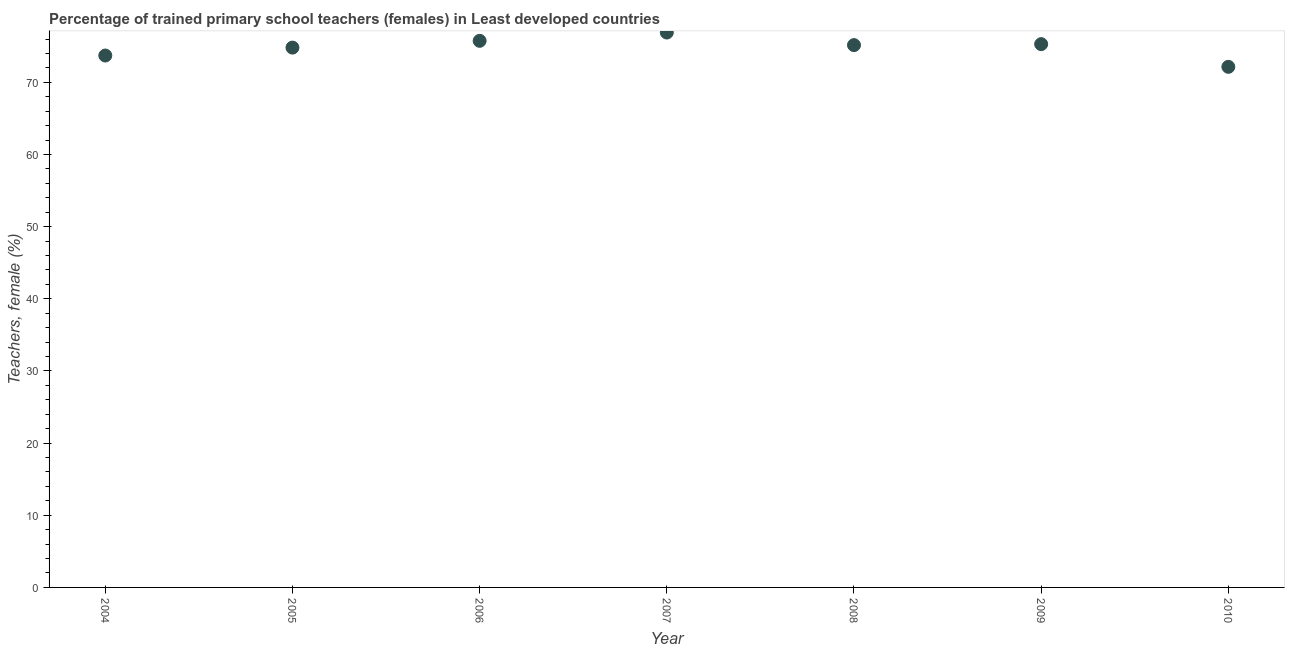What is the percentage of trained female teachers in 2006?
Keep it short and to the point. 75.75. Across all years, what is the maximum percentage of trained female teachers?
Your response must be concise. 76.9. Across all years, what is the minimum percentage of trained female teachers?
Give a very brief answer. 72.15. In which year was the percentage of trained female teachers minimum?
Offer a very short reply. 2010. What is the sum of the percentage of trained female teachers?
Keep it short and to the point. 523.77. What is the difference between the percentage of trained female teachers in 2006 and 2009?
Your response must be concise. 0.46. What is the average percentage of trained female teachers per year?
Your answer should be compact. 74.82. What is the median percentage of trained female teachers?
Make the answer very short. 75.16. Do a majority of the years between 2007 and 2010 (inclusive) have percentage of trained female teachers greater than 66 %?
Your response must be concise. Yes. What is the ratio of the percentage of trained female teachers in 2005 to that in 2009?
Ensure brevity in your answer.  0.99. Is the percentage of trained female teachers in 2007 less than that in 2008?
Your answer should be compact. No. Is the difference between the percentage of trained female teachers in 2006 and 2007 greater than the difference between any two years?
Your answer should be very brief. No. What is the difference between the highest and the second highest percentage of trained female teachers?
Make the answer very short. 1.15. Is the sum of the percentage of trained female teachers in 2009 and 2010 greater than the maximum percentage of trained female teachers across all years?
Your answer should be compact. Yes. What is the difference between the highest and the lowest percentage of trained female teachers?
Keep it short and to the point. 4.75. How many years are there in the graph?
Keep it short and to the point. 7. Are the values on the major ticks of Y-axis written in scientific E-notation?
Give a very brief answer. No. Does the graph contain any zero values?
Your answer should be very brief. No. What is the title of the graph?
Offer a terse response. Percentage of trained primary school teachers (females) in Least developed countries. What is the label or title of the Y-axis?
Your answer should be compact. Teachers, female (%). What is the Teachers, female (%) in 2004?
Provide a short and direct response. 73.71. What is the Teachers, female (%) in 2005?
Give a very brief answer. 74.81. What is the Teachers, female (%) in 2006?
Provide a succinct answer. 75.75. What is the Teachers, female (%) in 2007?
Offer a very short reply. 76.9. What is the Teachers, female (%) in 2008?
Provide a succinct answer. 75.16. What is the Teachers, female (%) in 2009?
Your response must be concise. 75.29. What is the Teachers, female (%) in 2010?
Give a very brief answer. 72.15. What is the difference between the Teachers, female (%) in 2004 and 2005?
Make the answer very short. -1.1. What is the difference between the Teachers, female (%) in 2004 and 2006?
Provide a short and direct response. -2.04. What is the difference between the Teachers, female (%) in 2004 and 2007?
Give a very brief answer. -3.19. What is the difference between the Teachers, female (%) in 2004 and 2008?
Make the answer very short. -1.44. What is the difference between the Teachers, female (%) in 2004 and 2009?
Provide a succinct answer. -1.58. What is the difference between the Teachers, female (%) in 2004 and 2010?
Your answer should be very brief. 1.57. What is the difference between the Teachers, female (%) in 2005 and 2006?
Your response must be concise. -0.94. What is the difference between the Teachers, female (%) in 2005 and 2007?
Your answer should be very brief. -2.09. What is the difference between the Teachers, female (%) in 2005 and 2008?
Keep it short and to the point. -0.35. What is the difference between the Teachers, female (%) in 2005 and 2009?
Give a very brief answer. -0.48. What is the difference between the Teachers, female (%) in 2005 and 2010?
Provide a succinct answer. 2.66. What is the difference between the Teachers, female (%) in 2006 and 2007?
Provide a succinct answer. -1.15. What is the difference between the Teachers, female (%) in 2006 and 2008?
Your answer should be compact. 0.59. What is the difference between the Teachers, female (%) in 2006 and 2009?
Offer a very short reply. 0.46. What is the difference between the Teachers, female (%) in 2006 and 2010?
Keep it short and to the point. 3.6. What is the difference between the Teachers, female (%) in 2007 and 2008?
Provide a succinct answer. 1.74. What is the difference between the Teachers, female (%) in 2007 and 2009?
Your response must be concise. 1.61. What is the difference between the Teachers, female (%) in 2007 and 2010?
Ensure brevity in your answer.  4.75. What is the difference between the Teachers, female (%) in 2008 and 2009?
Provide a short and direct response. -0.13. What is the difference between the Teachers, female (%) in 2008 and 2010?
Provide a short and direct response. 3.01. What is the difference between the Teachers, female (%) in 2009 and 2010?
Your answer should be very brief. 3.15. What is the ratio of the Teachers, female (%) in 2004 to that in 2005?
Offer a terse response. 0.98. What is the ratio of the Teachers, female (%) in 2004 to that in 2008?
Keep it short and to the point. 0.98. What is the ratio of the Teachers, female (%) in 2004 to that in 2010?
Keep it short and to the point. 1.02. What is the ratio of the Teachers, female (%) in 2005 to that in 2007?
Give a very brief answer. 0.97. What is the ratio of the Teachers, female (%) in 2005 to that in 2008?
Offer a very short reply. 0.99. What is the ratio of the Teachers, female (%) in 2006 to that in 2010?
Your response must be concise. 1.05. What is the ratio of the Teachers, female (%) in 2007 to that in 2008?
Your answer should be very brief. 1.02. What is the ratio of the Teachers, female (%) in 2007 to that in 2009?
Ensure brevity in your answer.  1.02. What is the ratio of the Teachers, female (%) in 2007 to that in 2010?
Offer a terse response. 1.07. What is the ratio of the Teachers, female (%) in 2008 to that in 2010?
Ensure brevity in your answer.  1.04. What is the ratio of the Teachers, female (%) in 2009 to that in 2010?
Your response must be concise. 1.04. 